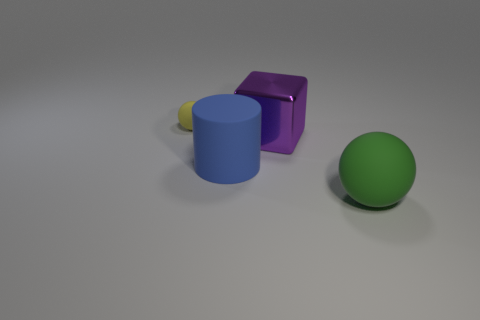Are there the same number of balls that are left of the shiny thing and purple blocks?
Provide a short and direct response. Yes. Is there anything else that is the same material as the big green object?
Ensure brevity in your answer.  Yes. There is a ball that is in front of the tiny thing; does it have the same color as the rubber thing to the left of the blue rubber cylinder?
Offer a terse response. No. How many rubber objects are on the left side of the purple shiny cube and in front of the purple metallic cube?
Offer a very short reply. 1. What number of other things are there of the same shape as the big blue object?
Your response must be concise. 0. Is the number of tiny yellow rubber things in front of the small ball greater than the number of purple shiny cubes?
Your response must be concise. No. What is the color of the large rubber object on the left side of the green ball?
Keep it short and to the point. Blue. What number of metal things are small yellow balls or purple things?
Offer a terse response. 1. There is a ball that is on the left side of the matte thing in front of the large blue cylinder; is there a blue cylinder on the left side of it?
Your answer should be compact. No. There is a large blue matte cylinder; what number of large metallic things are behind it?
Your answer should be compact. 1. 